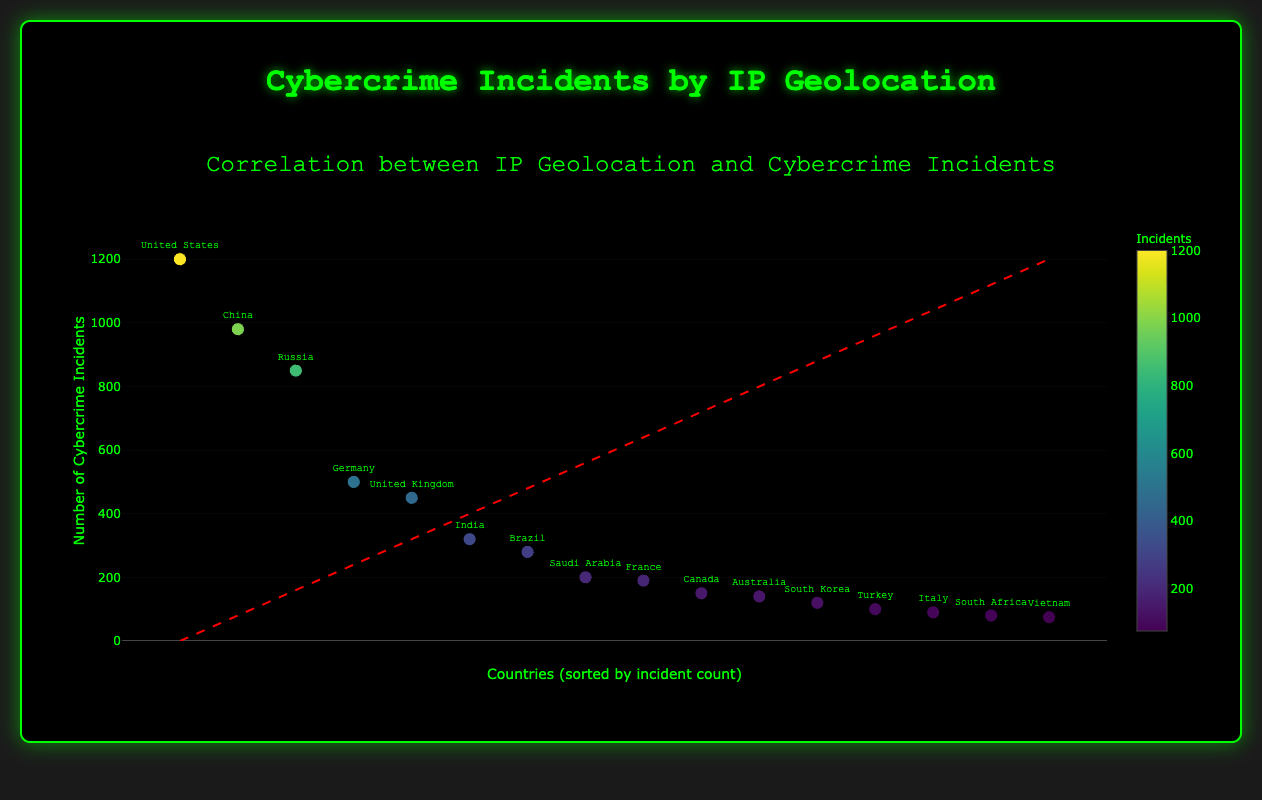What is the title of the scatter plot? The title is prominently displayed at the top of the scatter plot. It reads "Correlation between IP Geolocation and Cybercrime Incidents."
Answer: Correlation between IP Geolocation and Cybercrime Incidents How many countries are represented in the scatter plot? Each data point represents a country, and there are 16 data points.
Answer: 16 Which country has the highest number of cybercrime incidents? By examining the scatter plot, the data point at the top of the plot, labeled "United States," has the highest number of cybercrime incidents.
Answer: United States Is the color of the markers indicative of the number of cybercrime incidents? The color varies on a gradient from light to dark, with a color scale indicated on the plot showing that darker colors represent higher incident counts.
Answer: Yes What is the range of cybercrime incidents represented in the scatter plot? The y-axis starts at 0 and the maximum value just exceeds the largest data point, which is "United States" with 1200 incidents. This places the range from 0 to about 1320.
Answer: 0 to 1320 Between China and Russia, which country has more cybercrime incidents? China's data point is higher on the y-axis with 980 incidents, compared to Russia's 850.
Answer: China How many countries have fewer than 100 cybercrime incidents? By examining the data points, South Korea, Turkey, Italy, South Africa, and Vietnam all have fewer than 100 incidents.
Answer: 5 Is there a positive correlation between the IP geolocations and the frequency of cybercrime incidents? The trend line depicted on the scatter plot shows a general upward trend, which indicates a positive correlation.
Answer: Yes Which country has the closest number of cybercrime incidents to Canada? Canada has 150 incidents. The country with incidents closest to this number is Australia, which has 140 cybercrime incidents.
Answer: Australia What are the ip_geolocations of the countries with more than 500 cybercrime incidents? By examining the scatter plot, the labels above 500 on the y-axis correspond to the United States, China, and Russia.
Answer: United States, China, Russia 